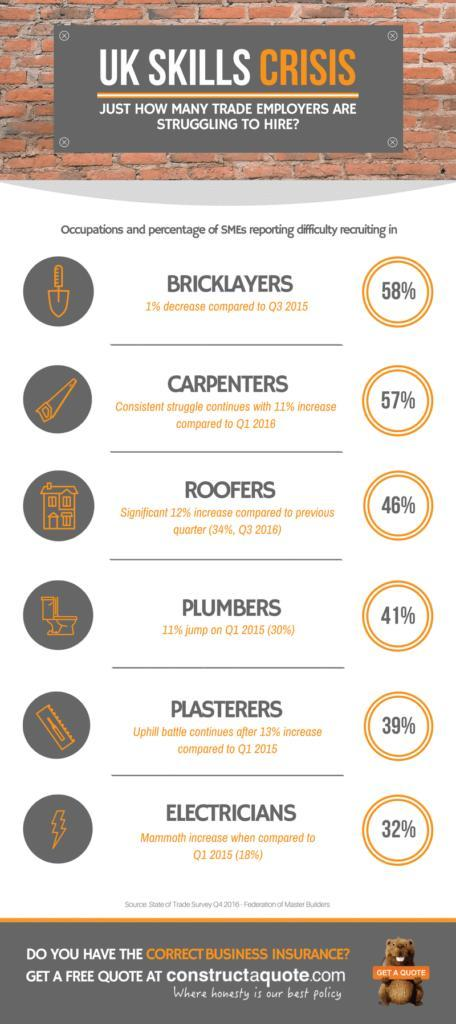What is the percentage of Carpenters in Q1 2016?
Answer the question with a short phrase. 46% What is the percentage of Bricklayers in the third quarter in 2015? 59% What is the increase in percentage for Electricians when compared to Q1 2015? 14% What is the percentage of Roofers in the fourth quarter in 2016? 46% What is the percentage of plasterers in Q1 2015? 26% Which colors have been used in the infographic, green, blue or orange? orange 